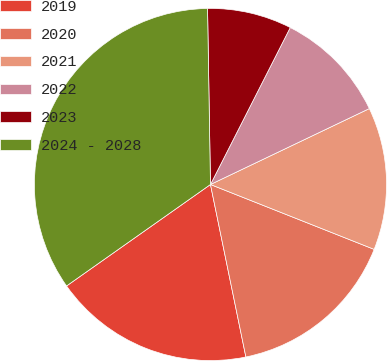Convert chart. <chart><loc_0><loc_0><loc_500><loc_500><pie_chart><fcel>2019<fcel>2020<fcel>2021<fcel>2022<fcel>2023<fcel>2024 - 2028<nl><fcel>18.45%<fcel>15.77%<fcel>13.1%<fcel>10.42%<fcel>7.75%<fcel>34.51%<nl></chart> 